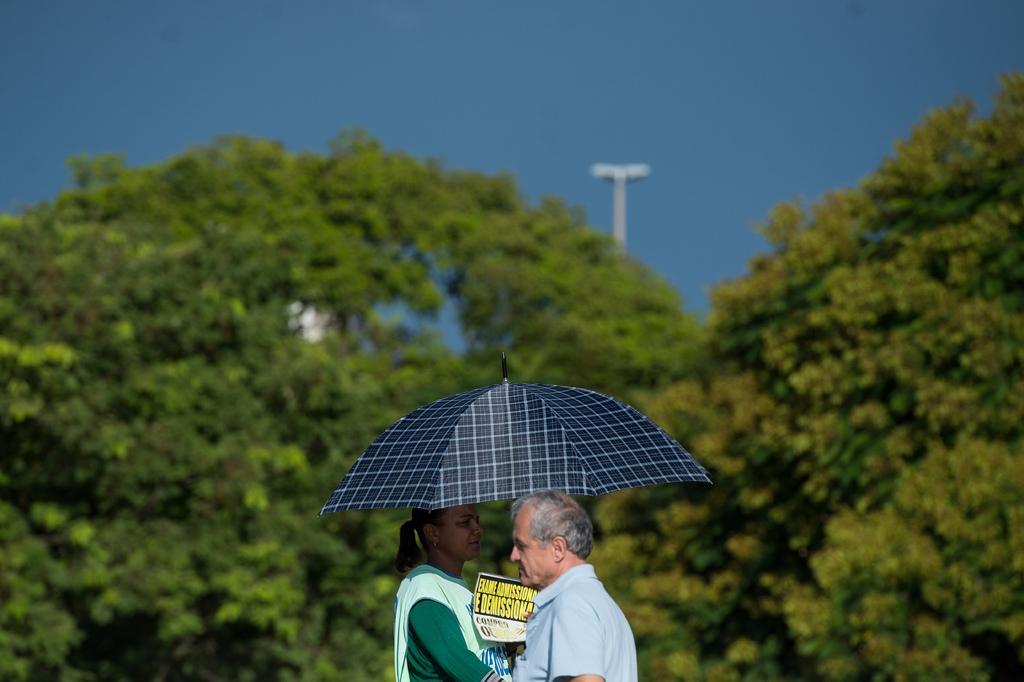How would you summarize this image in a sentence or two? In this image there is a woman holding an umbrella and a poster. Bottom of the image there is a person wearing a shirt. Background there are trees. Behind there is a street light. Top of the image there is sky. 